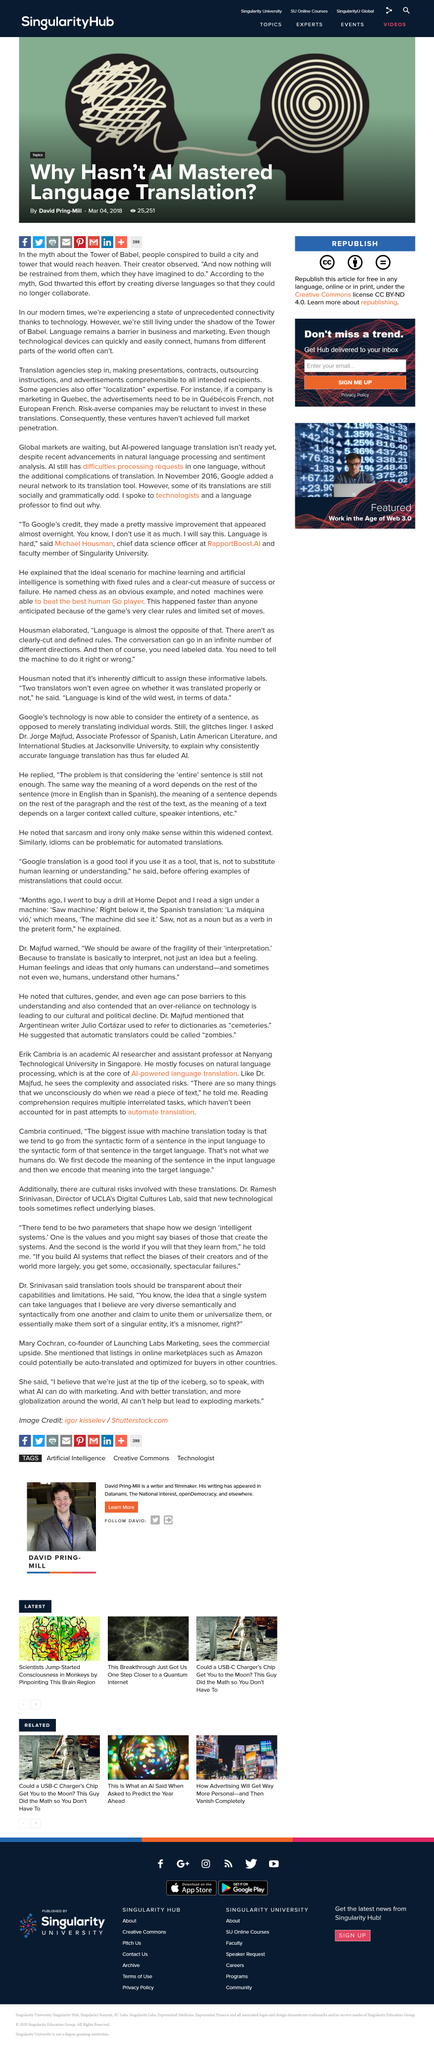Outline some significant characteristics in this image. The barrier of language presents a challenge in business and marketing, despite the advanced capabilities of technology to connect people from different parts of the world quickly and easily. The myth about the Tower of Babel was that people conspired to build a city and tower that would reach heaven, which was not possible according to the beliefs of the time. God thwarted the tower-builders' efforts by creating diverse languages, rendering collaboration impossible. 